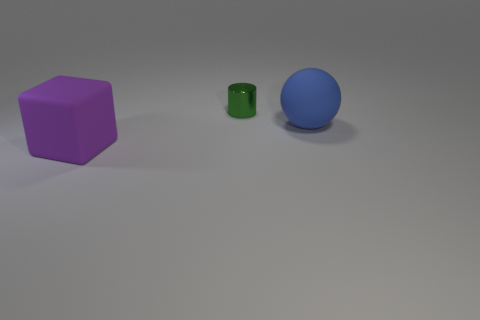Subtract all gray spheres. Subtract all cyan blocks. How many spheres are left? 1 Add 1 large green metal cylinders. How many objects exist? 4 Subtract all cubes. How many objects are left? 2 Add 3 large purple rubber objects. How many large purple rubber objects are left? 4 Add 1 rubber blocks. How many rubber blocks exist? 2 Subtract 0 blue blocks. How many objects are left? 3 Subtract all large purple rubber balls. Subtract all green cylinders. How many objects are left? 2 